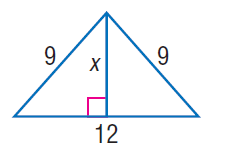Question: Find x.
Choices:
A. 3 \sqrt { 5 }
B. 4 \sqrt { 5 }
C. 5 \sqrt { 5 }
D. 6 \sqrt { 5 }
Answer with the letter. Answer: A 